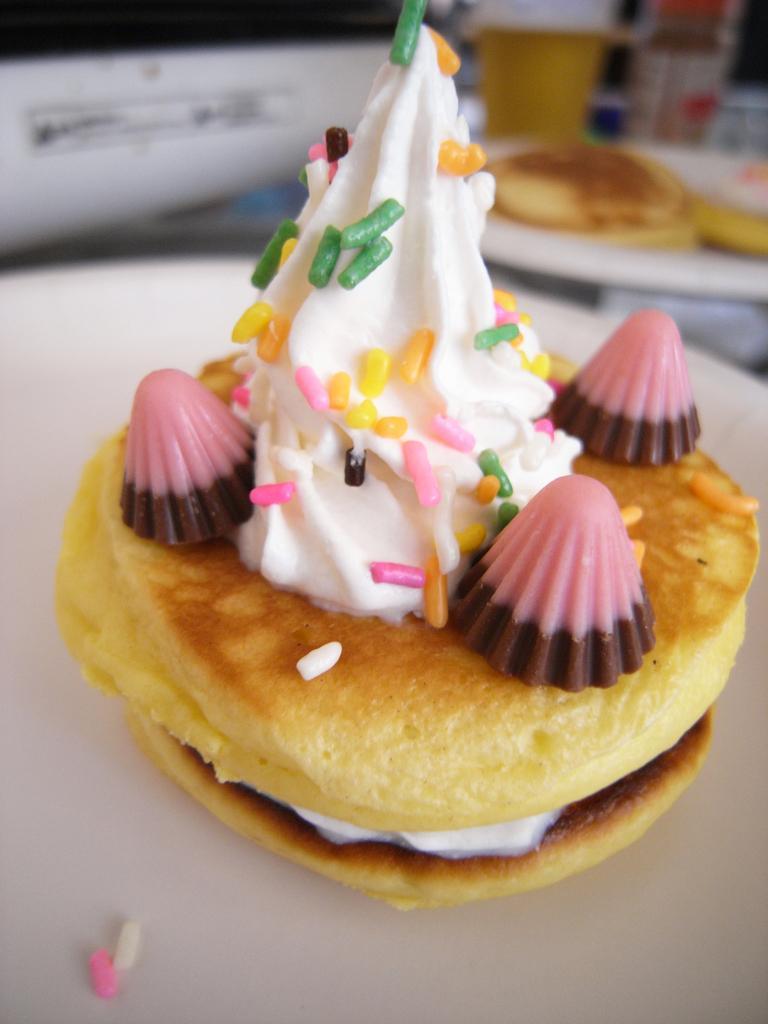In one or two sentences, can you explain what this image depicts? In this picture we can see some food on a white surface. There is a cup, bottle and food in another plate in the background. 